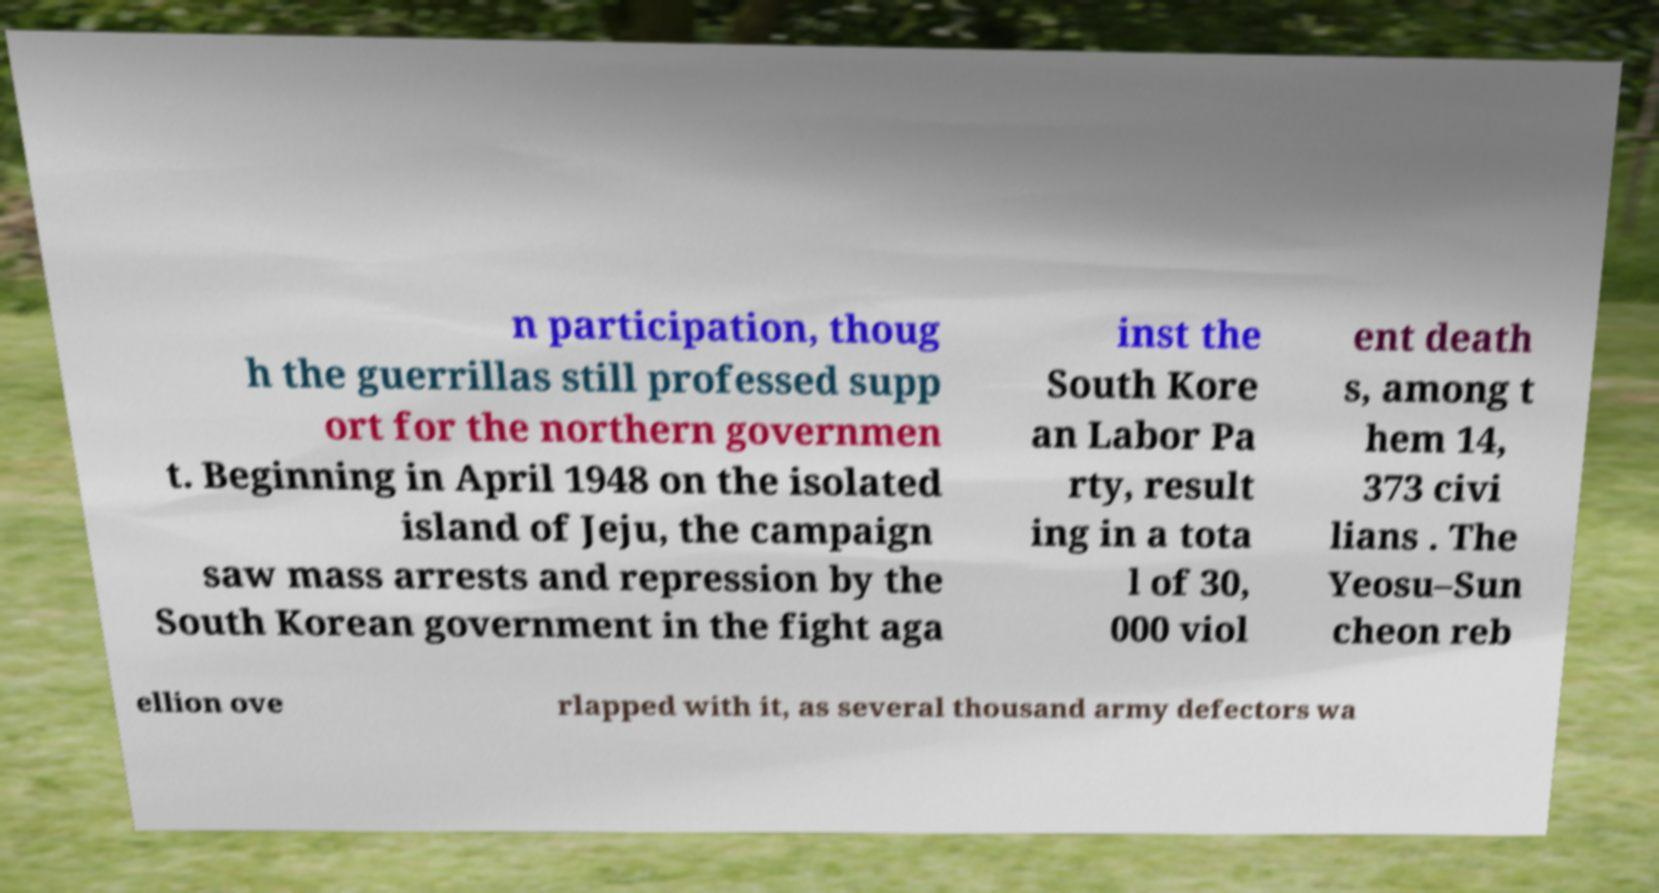Please identify and transcribe the text found in this image. n participation, thoug h the guerrillas still professed supp ort for the northern governmen t. Beginning in April 1948 on the isolated island of Jeju, the campaign saw mass arrests and repression by the South Korean government in the fight aga inst the South Kore an Labor Pa rty, result ing in a tota l of 30, 000 viol ent death s, among t hem 14, 373 civi lians . The Yeosu–Sun cheon reb ellion ove rlapped with it, as several thousand army defectors wa 